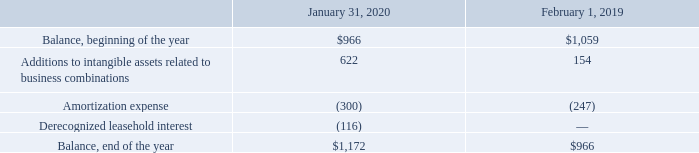Definite-Lived Intangible Assets, Net
The following table summarizes the changes in the carrying amount of definite-lived intangible assets during the periods presented (table in millions):
Upon adoption of Topic 842 on February 2, 2019, leasehold interest of $116 million related to favorable terms of certain ground lease agreements was derecognized and adjusted to the carrying amount of the operating lease ROU assets and classified as other assets on the consolidated balance sheets. Prior to adoption, these assets were classified as intangible assets, net on the consolidated balance sheets.
Which years does the table provide information for the changes in the carrying amount of definite-lived intangible assets? 2020, 2019. What was the amortization expense in 2020?
Answer scale should be: million. (300). What was the balance at the beginning of the year in 2019?
Answer scale should be: million. 1,059. What was the change in Additions to intangible assets between 2019 and 2020?
Answer scale should be: million. 622-154
Answer: 468. How many years did balance at the beginning of the year exceed $1,000 million? 2019
Answer: 1. What was the percentage change in the balance at the end of the year between 2019 and 2020?
Answer scale should be: percent. (1,172-966)/966
Answer: 21.33. 